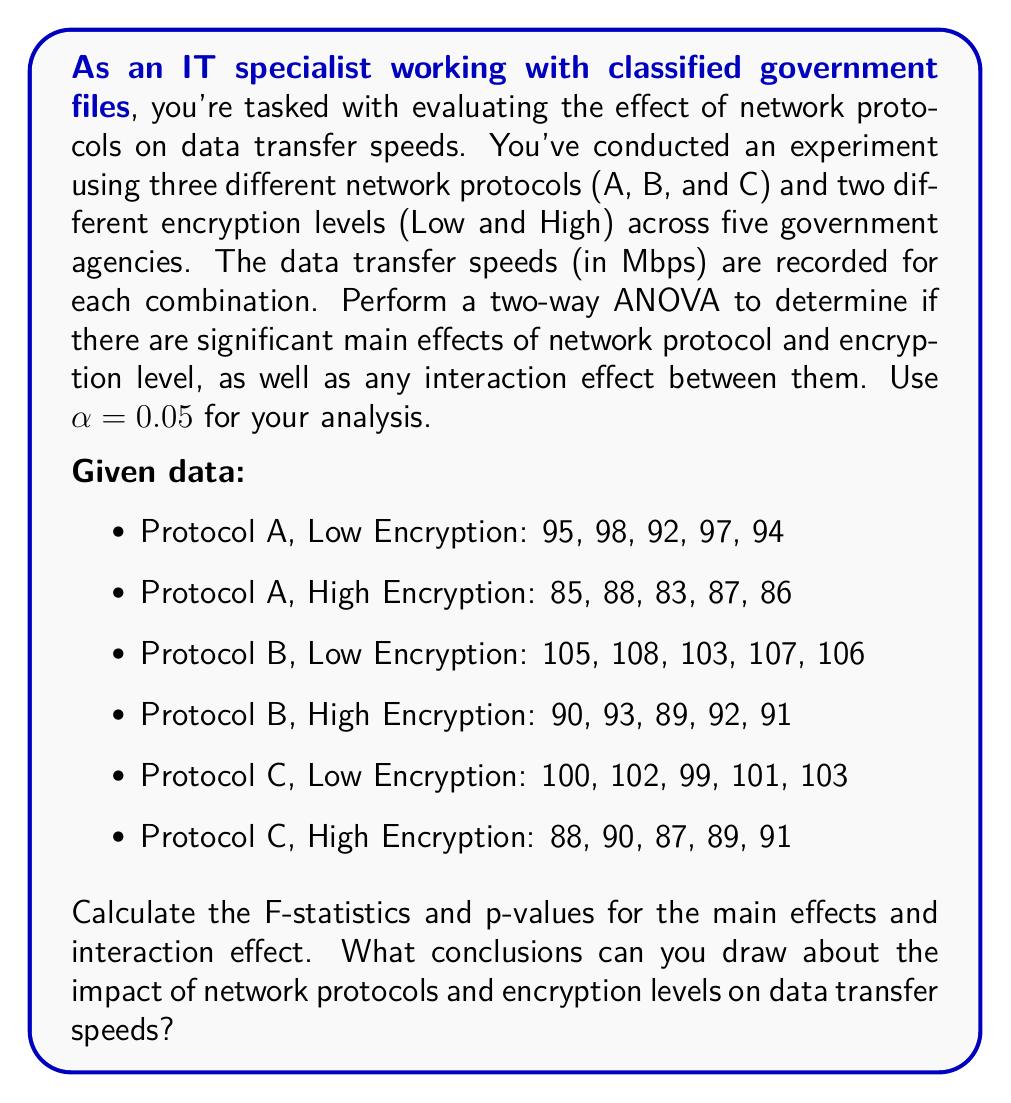Give your solution to this math problem. To perform a two-way ANOVA, we need to follow these steps:

1. Calculate the sum of squares for each factor (SSA for Protocol, SSB for Encryption), the interaction (SSAB), and the total (SST).
2. Calculate the degrees of freedom for each factor, interaction, and the total.
3. Calculate the mean squares for each factor, interaction, and error.
4. Calculate the F-statistics and p-values.

Step 1: Calculate sum of squares

First, let's calculate the grand mean:
$$\bar{X} = \frac{\sum_{i=1}^{n} X_i}{n} = \frac{2645}{30} = 88.17$$

Now, we can calculate the sum of squares for each factor and the total:

$$SSA = n_b \sum_{i=1}^a (\bar{X_i} - \bar{X})^2 = 10 \cdot [(90.5 - 88.17)^2 + (98.4 - 88.17)^2 + (95 - 88.17)^2] = 812.47$$

$$SSB = n_a \sum_{j=1}^b (\bar{X_j} - \bar{X})^2 = 15 \cdot [(101 - 88.17)^2 + (88.4 - 88.17)^2] = 1190.7$$

$$SST = \sum_{i=1}^n (X_i - \bar{X})^2 = 2291.37$$

$$SSAB = SS_{cells} - SSA - SSB = 2275.37 - 812.47 - 1190.7 = 272.2$$

$$SSE = SST - SS_{cells} = 2291.37 - 2275.37 = 16$$

Step 2: Calculate degrees of freedom

$$df_A = a - 1 = 3 - 1 = 2$$
$$df_B = b - 1 = 2 - 1 = 1$$
$$df_{AB} = (a-1)(b-1) = 2 \cdot 1 = 2$$
$$df_E = ab(n-1) = 3 \cdot 2 \cdot (5-1) = 24$$
$$df_T = N - 1 = 30 - 1 = 29$$

Step 3: Calculate mean squares

$$MSA = \frac{SSA}{df_A} = \frac{812.47}{2} = 406.24$$
$$MSB = \frac{SSB}{df_B} = \frac{1190.7}{1} = 1190.7$$
$$MSAB = \frac{SSAB}{df_{AB}} = \frac{272.2}{2} = 136.1$$
$$MSE = \frac{SSE}{df_E} = \frac{16}{24} = 0.67$$

Step 4: Calculate F-statistics and p-values

$$F_A = \frac{MSA}{MSE} = \frac{406.24}{0.67} = 606.33$$
$$F_B = \frac{MSB}{MSE} = \frac{1190.7}{0.67} = 1776.87$$
$$F_{AB} = \frac{MSAB}{MSE} = \frac{136.1}{0.67} = 203.13$$

Using an F-distribution calculator with α = 0.05:

For Protocol: F(2, 24) = 606.33, p < 0.0001
For Encryption: F(1, 24) = 1776.87, p < 0.0001
For Interaction: F(2, 24) = 203.13, p < 0.0001

All p-values are less than the significance level of 0.05, indicating that there are significant main effects for both network protocol and encryption level, as well as a significant interaction effect between them.
Answer: Based on the two-way ANOVA results:

1. Main effect of Network Protocol: F(2, 24) = 606.33, p < 0.0001
2. Main effect of Encryption Level: F(1, 24) = 1776.87, p < 0.0001
3. Interaction effect: F(2, 24) = 203.13, p < 0.0001

Conclusions:
1. There is a significant main effect of network protocol on data transfer speeds.
2. There is a significant main effect of encryption level on data transfer speeds.
3. There is a significant interaction effect between network protocol and encryption level on data transfer speeds.

These results suggest that both network protocol and encryption level independently affect data transfer speeds, and their combined effect is also significant. Further post-hoc tests would be needed to determine which specific protocols or encryption levels differ significantly from each other. 